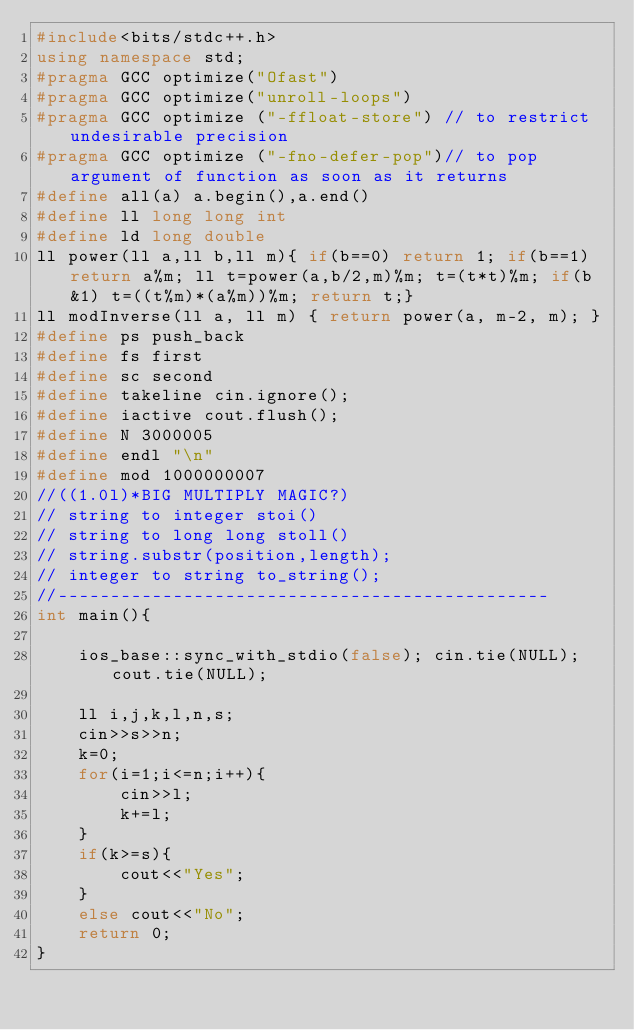<code> <loc_0><loc_0><loc_500><loc_500><_C++_>#include<bits/stdc++.h>
using namespace std;
#pragma GCC optimize("Ofast")
#pragma GCC optimize("unroll-loops")
#pragma GCC optimize ("-ffloat-store") // to restrict undesirable precision
#pragma GCC optimize ("-fno-defer-pop")// to pop argument of function as soon as it returns
#define all(a) a.begin(),a.end()
#define ll long long int
#define ld long double
ll power(ll a,ll b,ll m){ if(b==0) return 1; if(b==1) return a%m; ll t=power(a,b/2,m)%m; t=(t*t)%m; if(b&1) t=((t%m)*(a%m))%m; return t;}
ll modInverse(ll a, ll m) { return power(a, m-2, m); }
#define ps push_back
#define fs first
#define sc second
#define takeline cin.ignore();
#define iactive cout.flush();
#define N 3000005
#define endl "\n"
#define mod 1000000007
//((1.0l)*BIG MULTIPLY MAGIC?)
// string to integer stoi()
// string to long long stoll()
// string.substr(position,length);
// integer to string to_string();
//-----------------------------------------------
int main(){
	
	ios_base::sync_with_stdio(false); cin.tie(NULL); cout.tie(NULL);
	
	ll i,j,k,l,n,s;
	cin>>s>>n;
	k=0;
	for(i=1;i<=n;i++){
		cin>>l;
		k+=l;
	}
	if(k>=s){
		cout<<"Yes";
	}
	else cout<<"No";
	return 0;
}</code> 